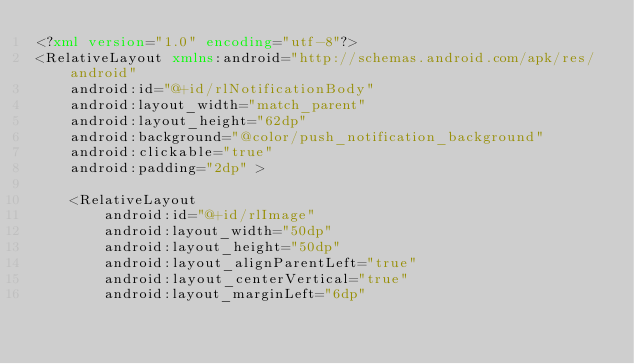<code> <loc_0><loc_0><loc_500><loc_500><_XML_><?xml version="1.0" encoding="utf-8"?>
<RelativeLayout xmlns:android="http://schemas.android.com/apk/res/android"
    android:id="@+id/rlNotificationBody"
    android:layout_width="match_parent"
    android:layout_height="62dp"
    android:background="@color/push_notification_background"
    android:clickable="true"
    android:padding="2dp" >

    <RelativeLayout
        android:id="@+id/rlImage"
        android:layout_width="50dp"
        android:layout_height="50dp"
        android:layout_alignParentLeft="true"
        android:layout_centerVertical="true"
        android:layout_marginLeft="6dp"</code> 